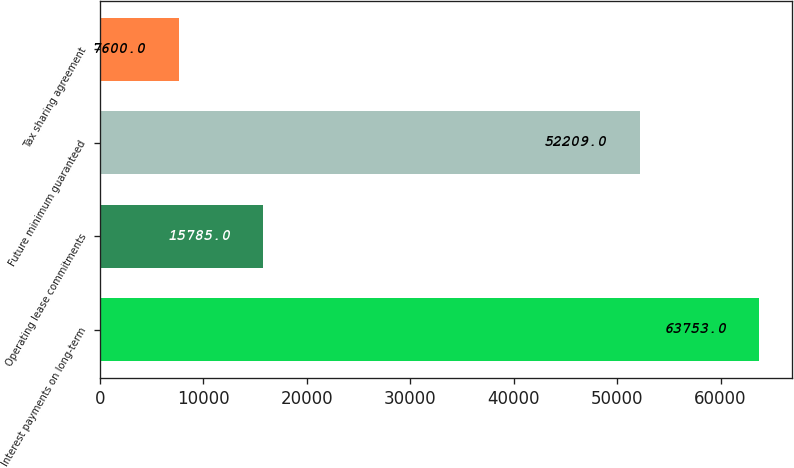Convert chart to OTSL. <chart><loc_0><loc_0><loc_500><loc_500><bar_chart><fcel>Interest payments on long-term<fcel>Operating lease commitments<fcel>Future minimum guaranteed<fcel>Tax sharing agreement<nl><fcel>63753<fcel>15785<fcel>52209<fcel>7600<nl></chart> 